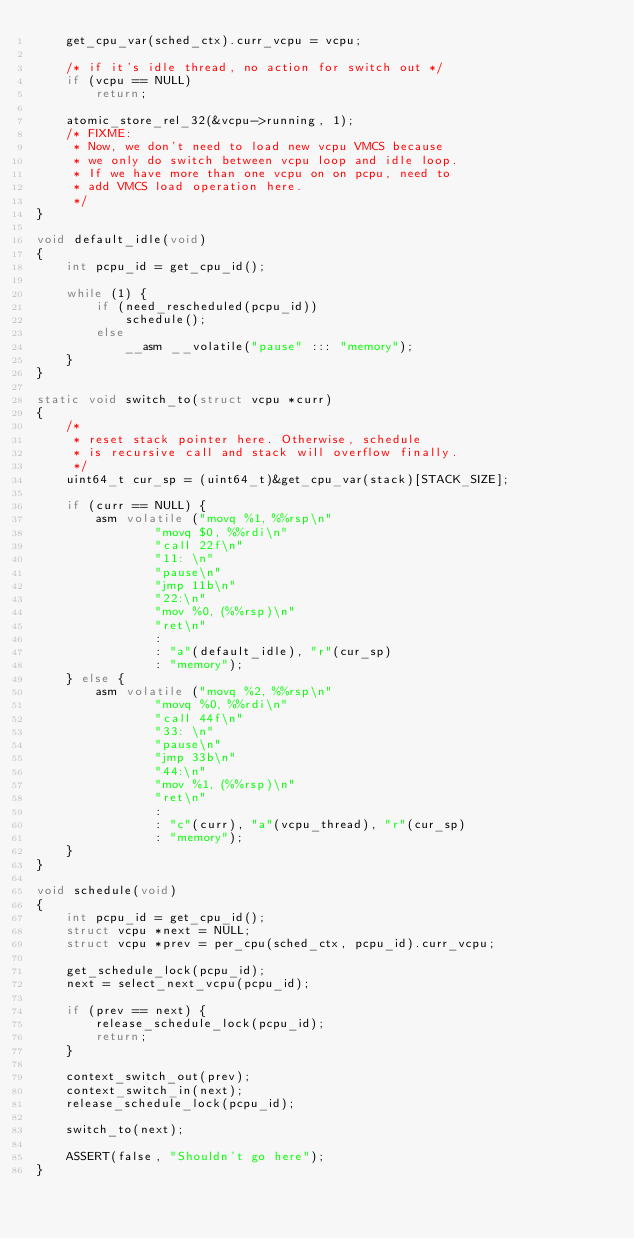<code> <loc_0><loc_0><loc_500><loc_500><_C_>	get_cpu_var(sched_ctx).curr_vcpu = vcpu;

	/* if it's idle thread, no action for switch out */
	if (vcpu == NULL)
		return;

	atomic_store_rel_32(&vcpu->running, 1);
	/* FIXME:
	 * Now, we don't need to load new vcpu VMCS because
	 * we only do switch between vcpu loop and idle loop.
	 * If we have more than one vcpu on on pcpu, need to
	 * add VMCS load operation here.
	 */
}

void default_idle(void)
{
	int pcpu_id = get_cpu_id();

	while (1) {
		if (need_rescheduled(pcpu_id))
			schedule();
		else
			__asm __volatile("pause" ::: "memory");
	}
}

static void switch_to(struct vcpu *curr)
{
	/*
	 * reset stack pointer here. Otherwise, schedule
	 * is recursive call and stack will overflow finally.
	 */
	uint64_t cur_sp = (uint64_t)&get_cpu_var(stack)[STACK_SIZE];

	if (curr == NULL) {
		asm volatile ("movq %1, %%rsp\n"
				"movq $0, %%rdi\n"
				"call 22f\n"
				"11: \n"
				"pause\n"
				"jmp 11b\n"
				"22:\n"
				"mov %0, (%%rsp)\n"
				"ret\n"
				:
				: "a"(default_idle), "r"(cur_sp)
				: "memory");
	} else {
		asm volatile ("movq %2, %%rsp\n"
				"movq %0, %%rdi\n"
				"call 44f\n"
				"33: \n"
				"pause\n"
				"jmp 33b\n"
				"44:\n"
				"mov %1, (%%rsp)\n"
				"ret\n"
				:
				: "c"(curr), "a"(vcpu_thread), "r"(cur_sp)
				: "memory");
	}
}

void schedule(void)
{
	int pcpu_id = get_cpu_id();
	struct vcpu *next = NULL;
	struct vcpu *prev = per_cpu(sched_ctx, pcpu_id).curr_vcpu;

	get_schedule_lock(pcpu_id);
	next = select_next_vcpu(pcpu_id);

	if (prev == next) {
		release_schedule_lock(pcpu_id);
		return;
	}

	context_switch_out(prev);
	context_switch_in(next);
	release_schedule_lock(pcpu_id);

	switch_to(next);

	ASSERT(false, "Shouldn't go here");
}
</code> 